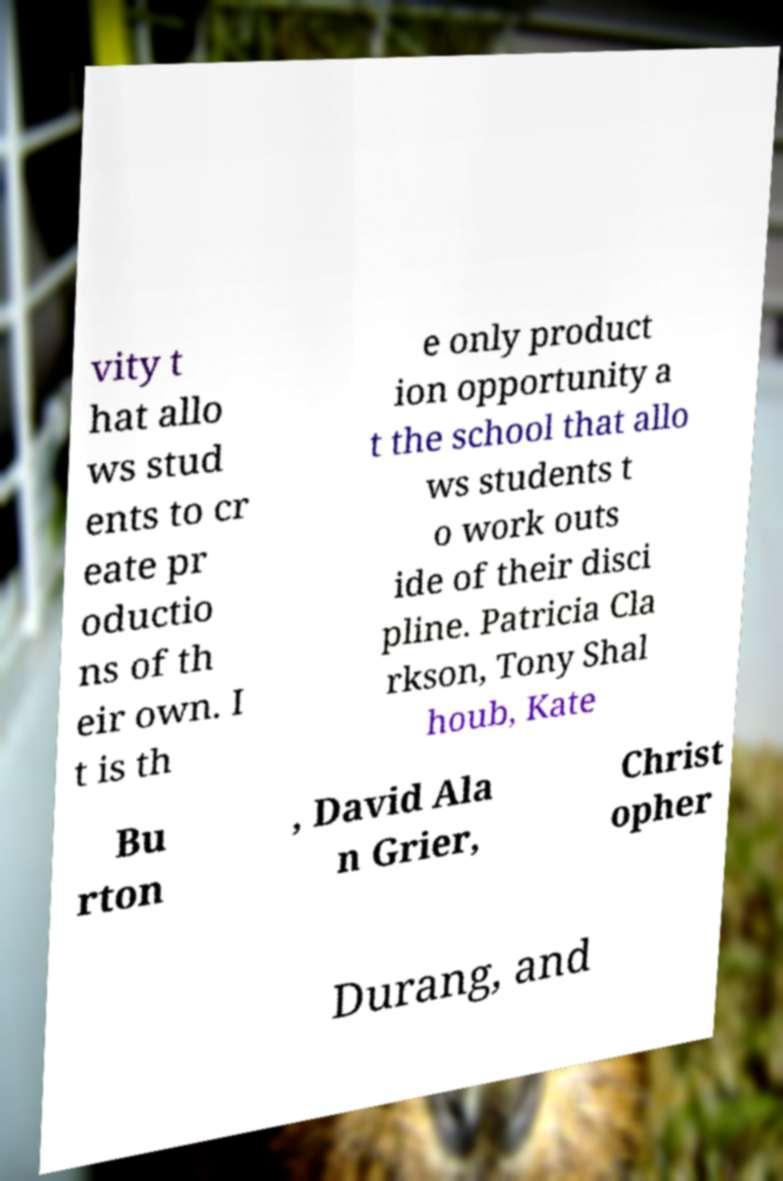Could you assist in decoding the text presented in this image and type it out clearly? vity t hat allo ws stud ents to cr eate pr oductio ns of th eir own. I t is th e only product ion opportunity a t the school that allo ws students t o work outs ide of their disci pline. Patricia Cla rkson, Tony Shal houb, Kate Bu rton , David Ala n Grier, Christ opher Durang, and 